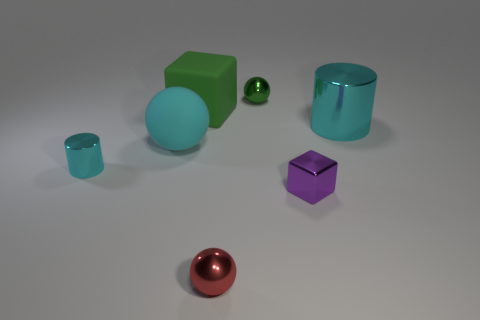Subtract all metal spheres. How many spheres are left? 1 Add 1 green rubber cylinders. How many objects exist? 8 Subtract all red spheres. How many spheres are left? 2 Subtract all spheres. How many objects are left? 4 Add 7 large red cubes. How many large red cubes exist? 7 Subtract 0 red blocks. How many objects are left? 7 Subtract all brown blocks. Subtract all yellow balls. How many blocks are left? 2 Subtract all rubber balls. Subtract all small green things. How many objects are left? 5 Add 4 green rubber things. How many green rubber things are left? 5 